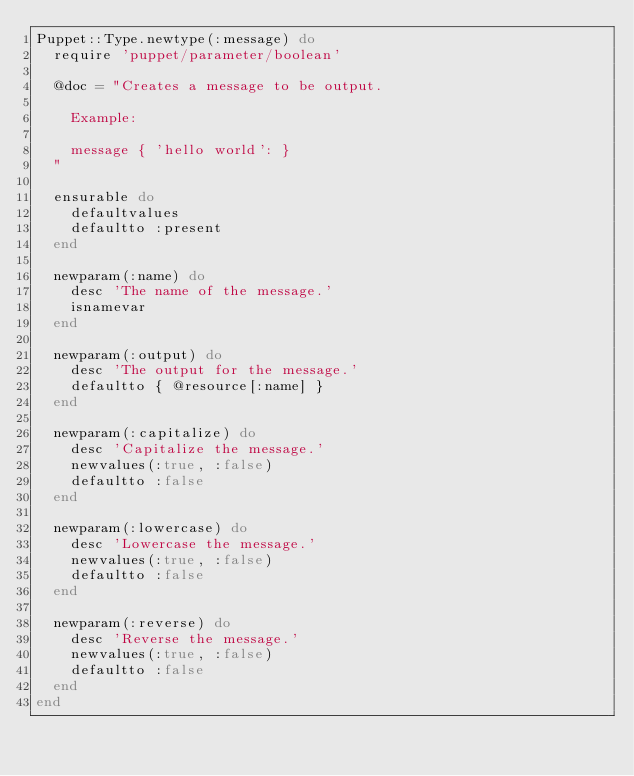<code> <loc_0><loc_0><loc_500><loc_500><_Ruby_>Puppet::Type.newtype(:message) do
  require 'puppet/parameter/boolean'

  @doc = "Creates a message to be output.

    Example:

    message { 'hello world': }
  "

  ensurable do
    defaultvalues
    defaultto :present
  end

  newparam(:name) do
    desc 'The name of the message.'
    isnamevar
  end

  newparam(:output) do
    desc 'The output for the message.'
    defaultto { @resource[:name] }
  end

  newparam(:capitalize) do
    desc 'Capitalize the message.'
    newvalues(:true, :false)
    defaultto :false
  end

  newparam(:lowercase) do
    desc 'Lowercase the message.'
    newvalues(:true, :false)
    defaultto :false
  end

  newparam(:reverse) do
    desc 'Reverse the message.'
    newvalues(:true, :false)
    defaultto :false
  end
end
</code> 